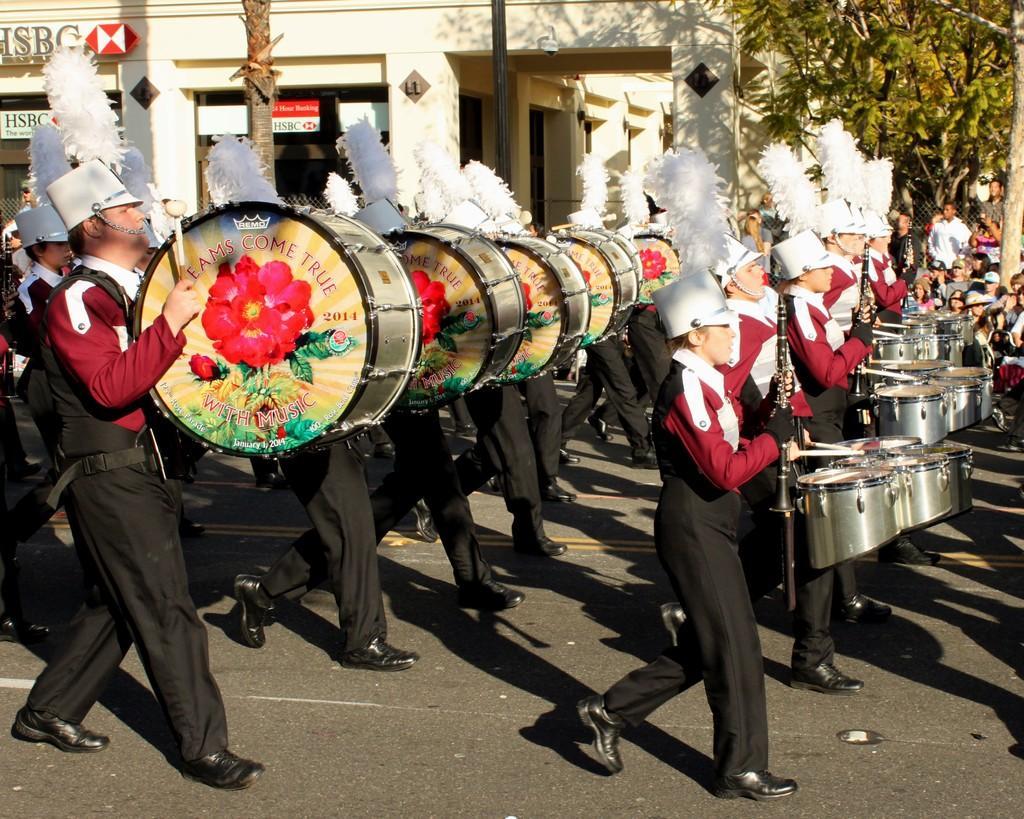How would you summarize this image in a sentence or two? The picture is outside a building. The people are walking by the road are playing drum. They are wearing uniform and white hat. In the background there is a tree and building. 